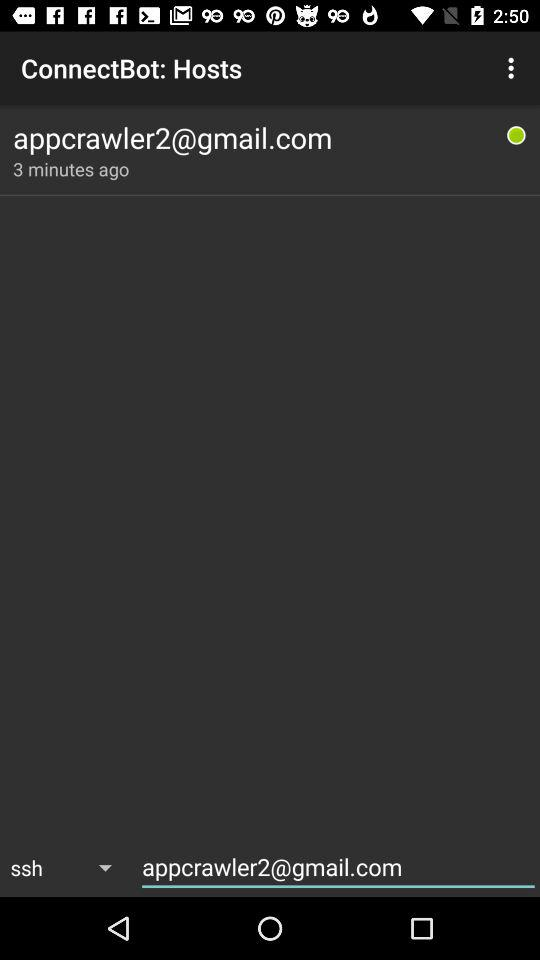How many minutes ago was the last time this host was used?
Answer the question using a single word or phrase. 3 